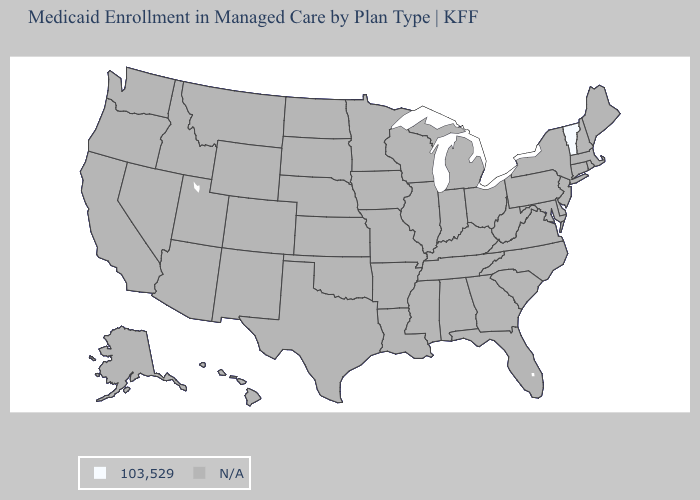What is the value of Utah?
Write a very short answer. N/A. Is the legend a continuous bar?
Keep it brief. No. Name the states that have a value in the range 103,529?
Be succinct. Vermont. What is the lowest value in the USA?
Short answer required. 103,529. What is the value of Idaho?
Give a very brief answer. N/A. What is the value of Connecticut?
Answer briefly. N/A. How many symbols are there in the legend?
Write a very short answer. 2. What is the lowest value in the Northeast?
Give a very brief answer. 103,529. Name the states that have a value in the range 103,529?
Concise answer only. Vermont. 